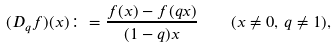<formula> <loc_0><loc_0><loc_500><loc_500>( D _ { q } f ) ( x ) \colon = \frac { f ( x ) - f ( q x ) } { ( 1 - q ) x } \quad ( x \ne 0 , \, q \ne 1 ) ,</formula> 